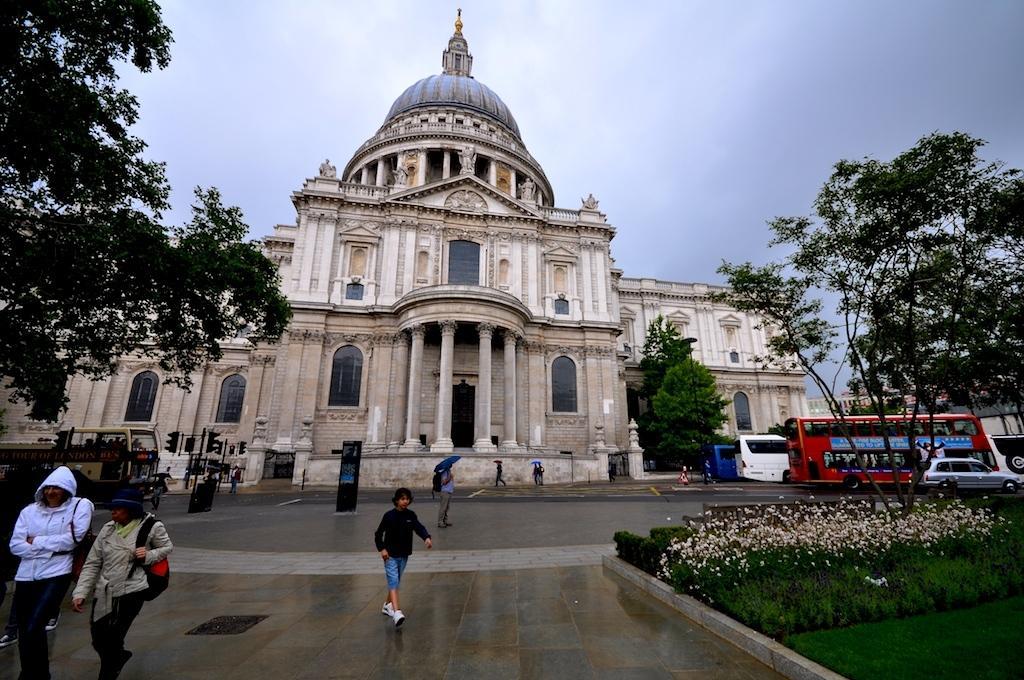Describe this image in one or two sentences. This picture is clicked outside. In the center we can see the group of persons and we can see the group of vehicles. On the right we can see the green grass, flowers and plants and we can see the traffic lights, poles and the trees and we can see the building, windows and pillars of the building. In the background we can see the sky and some other objects. 